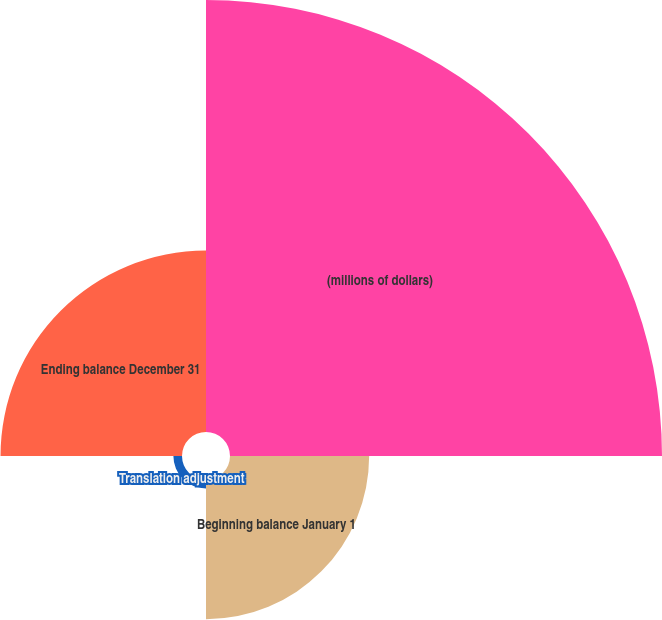Convert chart. <chart><loc_0><loc_0><loc_500><loc_500><pie_chart><fcel>(millions of dollars)<fcel>Beginning balance January 1<fcel>Translation adjustment<fcel>Ending balance December 31<nl><fcel>56.75%<fcel>18.28%<fcel>1.13%<fcel>23.84%<nl></chart> 